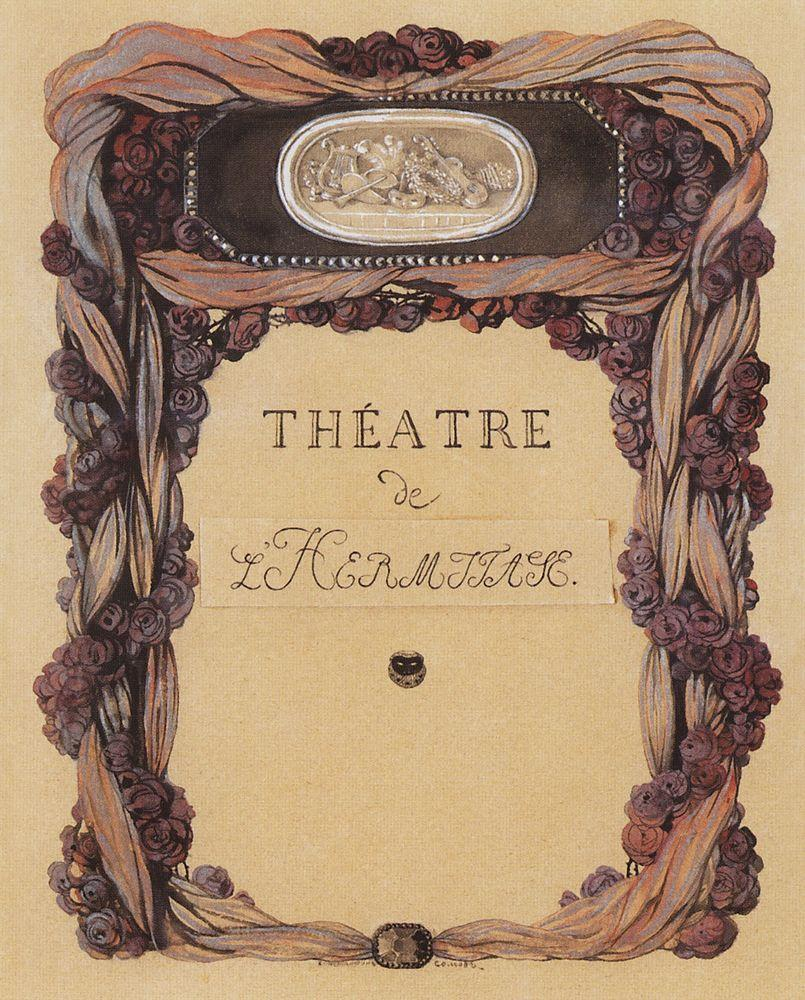Can you describe the main features of this image for me? This image is a striking example of an Art Nouveau poster, primarily designed for 'Théâtre de L'Horloge'. At its center, an elegantly crafted oval mirror showcases a vignette of a man and a woman conversing in a lush garden, symbolizing perhaps a scene from a play. This central image is framed by an ornamental border lushly adorned with intertwining roses in shades of purple and red, set against a beige background that enhances the floral motif. The text 'Théâtre de L'Horloge' is prominently displayed at the bottom, integrating seamlessly with the artistic theme. The intricate details and floral elements are quintessential of the Art Nouveau style, aimed at capturing the essence of beauty and nature in art. 